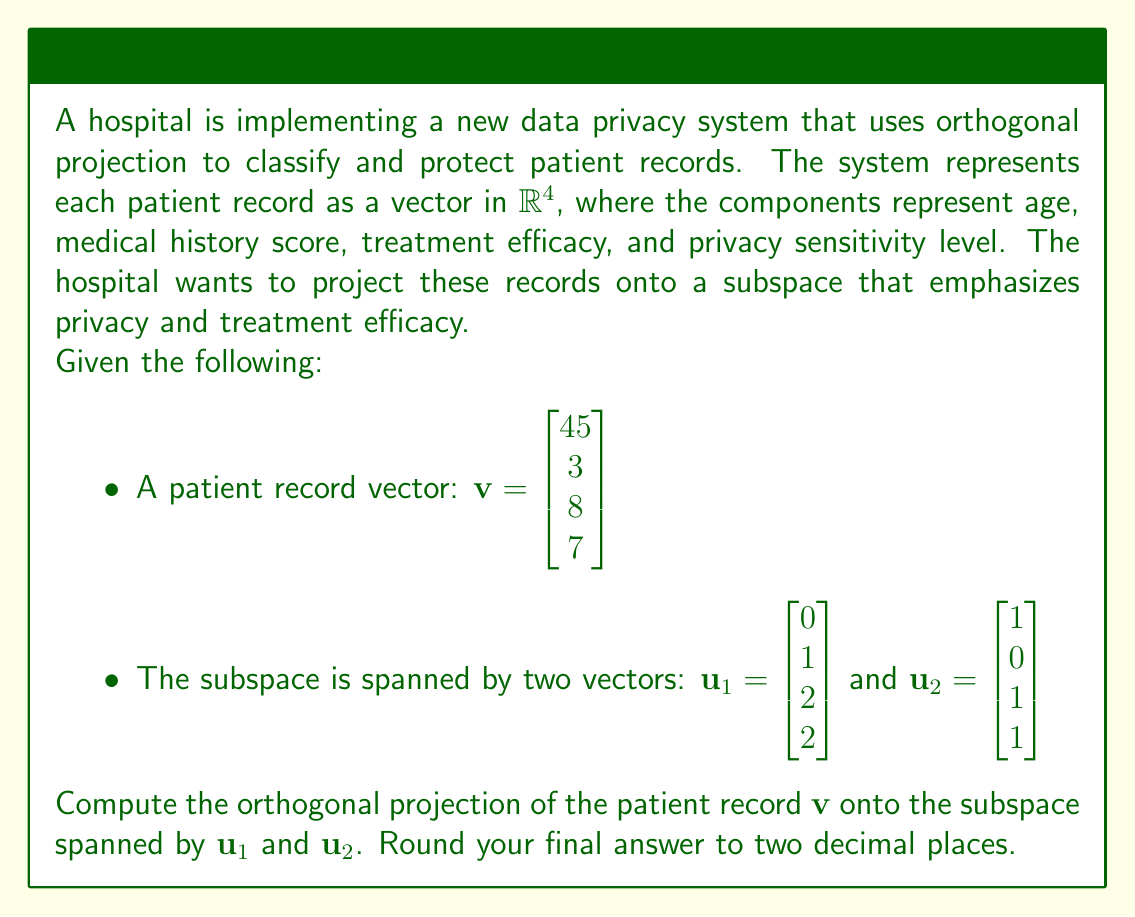Provide a solution to this math problem. To find the orthogonal projection of $\mathbf{v}$ onto the subspace spanned by $\mathbf{u}_1$ and $\mathbf{u}_2$, we'll follow these steps:

1) First, we need to create an orthonormal basis for the subspace using the Gram-Schmidt process:

   Let $\mathbf{e}_1 = \frac{\mathbf{u}_1}{\|\mathbf{u}_1\|}$
   $\mathbf{e}_1 = \frac{1}{\sqrt{1^2 + 2^2 + 2^2}} \begin{bmatrix} 0 \\ 1 \\ 2 \\ 2 \end{bmatrix} = \frac{1}{3} \begin{bmatrix} 0 \\ 1 \\ 2 \\ 2 \end{bmatrix}$

   $\mathbf{e}_2 = \mathbf{u}_2 - (\mathbf{u}_2 \cdot \mathbf{e}_1)\mathbf{e}_1$
   $= \begin{bmatrix} 1 \\ 0 \\ 1 \\ 1 \end{bmatrix} - (\frac{1}{3}(0+0+2+2)) \begin{bmatrix} 0 \\ 1 \\ 2 \\ 2 \end{bmatrix}$
   $= \begin{bmatrix} 1 \\ 0 \\ 1 \\ 1 \end{bmatrix} - \frac{4}{3} \begin{bmatrix} 0 \\ 1 \\ 2 \\ 2 \end{bmatrix}$
   $= \begin{bmatrix} 1 \\ -\frac{4}{3} \\ -\frac{5}{3} \\ -\frac{5}{3} \end{bmatrix}$

   Normalizing $\mathbf{e}_2$:
   $\mathbf{e}_2 = \frac{\mathbf{e}_2}{\|\mathbf{e}_2\|} = \frac{3}{\sqrt{41}} \begin{bmatrix} 1 \\ -\frac{4}{3} \\ -\frac{5}{3} \\ -\frac{5}{3} \end{bmatrix}$

2) Now we can project $\mathbf{v}$ onto this orthonormal basis:

   $\text{proj}_W \mathbf{v} = (\mathbf{v} \cdot \mathbf{e}_1)\mathbf{e}_1 + (\mathbf{v} \cdot \mathbf{e}_2)\mathbf{e}_2$

3) Calculate $\mathbf{v} \cdot \mathbf{e}_1$:
   $\mathbf{v} \cdot \mathbf{e}_1 = \frac{1}{3}(45 \cdot 0 + 3 \cdot 1 + 8 \cdot 2 + 7 \cdot 2) = \frac{1}{3}(3 + 16 + 14) = 11$

4) Calculate $\mathbf{v} \cdot \mathbf{e}_2$:
   $\mathbf{v} \cdot \mathbf{e}_2 = \frac{3}{\sqrt{41}}(45 \cdot 1 + 3 \cdot (-\frac{4}{3}) + 8 \cdot (-\frac{5}{3}) + 7 \cdot (-\frac{5}{3}))$
   $= \frac{3}{\sqrt{41}}(45 - 4 - \frac{40}{3} - \frac{35}{3}) = \frac{3}{\sqrt{41}}(45 - 4 - 25) = \frac{48}{\sqrt{41}}$

5) Now we can compute the projection:
   $\text{proj}_W \mathbf{v} = 11 \cdot \frac{1}{3} \begin{bmatrix} 0 \\ 1 \\ 2 \\ 2 \end{bmatrix} + \frac{48}{\sqrt{41}} \cdot \frac{3}{\sqrt{41}} \begin{bmatrix} 1 \\ -\frac{4}{3} \\ -\frac{5}{3} \\ -\frac{5}{3} \end{bmatrix}$

6) Simplifying:
   $\text{proj}_W \mathbf{v} = \begin{bmatrix} 0 \\ \frac{11}{3} \\ \frac{22}{3} \\ \frac{22}{3} \end{bmatrix} + \frac{144}{41} \begin{bmatrix} 1 \\ -\frac{4}{3} \\ -\frac{5}{3} \\ -\frac{5}{3} \end{bmatrix}$

7) Final result:
   $\text{proj}_W \mathbf{v} = \begin{bmatrix} \frac{144}{41} \\ \frac{11}{3} - \frac{192}{41} \\ \frac{22}{3} - \frac{240}{41} \\ \frac{22}{3} - \frac{240}{41} \end{bmatrix}$
Answer: The orthogonal projection of the patient record onto the subspace is:

$$\text{proj}_W \mathbf{v} \approx \begin{bmatrix} 3.51 \\ 0.95 \\ 1.29 \\ 1.29 \end{bmatrix}$$

(rounded to two decimal places) 